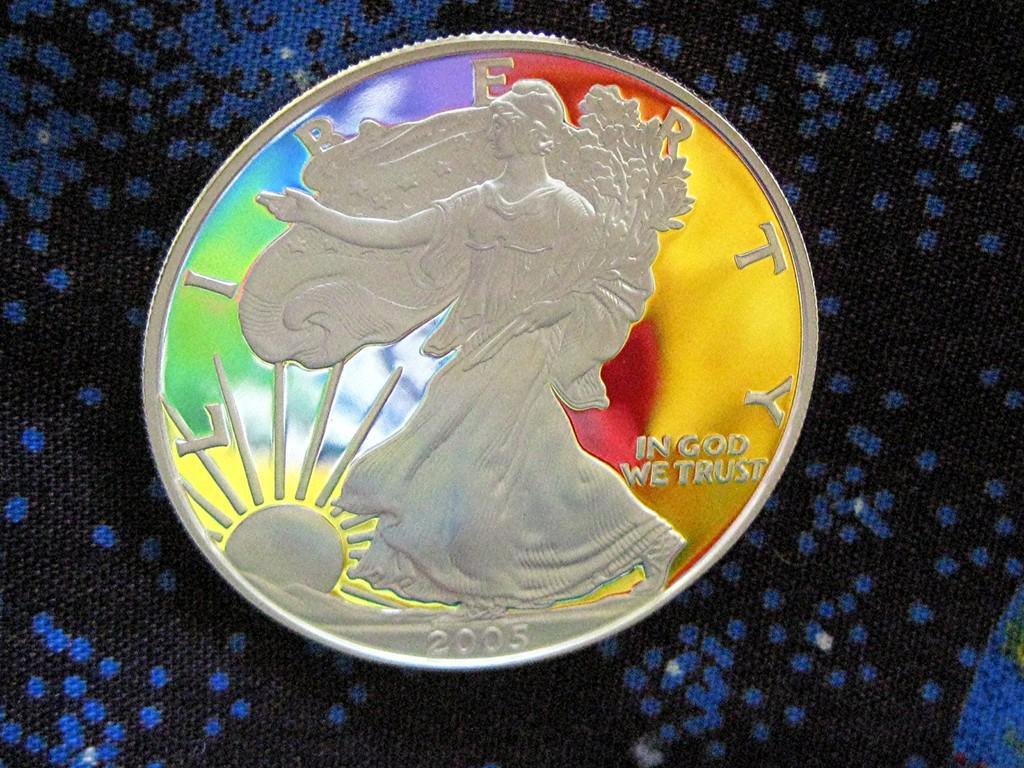Describe this image in one or two sentences. In this image I can see a colorful coin on the black and blue color surface. 